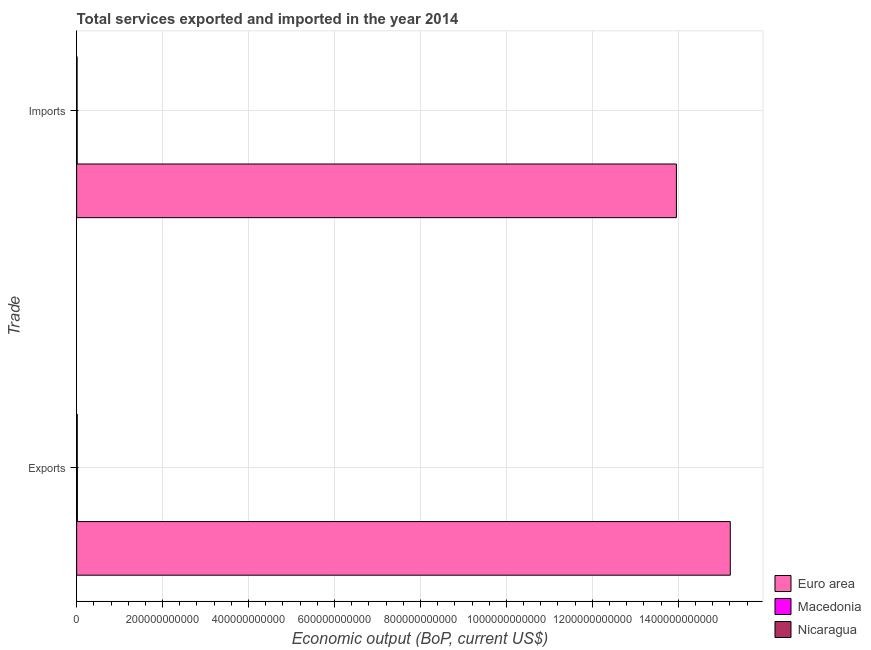How many different coloured bars are there?
Ensure brevity in your answer.  3. Are the number of bars per tick equal to the number of legend labels?
Your answer should be compact. Yes. Are the number of bars on each tick of the Y-axis equal?
Provide a short and direct response. Yes. How many bars are there on the 1st tick from the bottom?
Ensure brevity in your answer.  3. What is the label of the 2nd group of bars from the top?
Give a very brief answer. Exports. What is the amount of service imports in Nicaragua?
Give a very brief answer. 9.60e+08. Across all countries, what is the maximum amount of service exports?
Your answer should be very brief. 1.52e+12. Across all countries, what is the minimum amount of service exports?
Make the answer very short. 1.39e+09. In which country was the amount of service exports minimum?
Offer a very short reply. Nicaragua. What is the total amount of service exports in the graph?
Your answer should be compact. 1.52e+12. What is the difference between the amount of service exports in Euro area and that in Nicaragua?
Provide a succinct answer. 1.52e+12. What is the difference between the amount of service imports in Nicaragua and the amount of service exports in Euro area?
Keep it short and to the point. -1.52e+12. What is the average amount of service exports per country?
Your answer should be very brief. 5.08e+11. What is the difference between the amount of service imports and amount of service exports in Nicaragua?
Ensure brevity in your answer.  -4.28e+08. What is the ratio of the amount of service imports in Euro area to that in Nicaragua?
Your response must be concise. 1453.93. What does the 1st bar from the top in Exports represents?
Make the answer very short. Nicaragua. What does the 3rd bar from the bottom in Imports represents?
Your answer should be compact. Nicaragua. How many countries are there in the graph?
Keep it short and to the point. 3. What is the difference between two consecutive major ticks on the X-axis?
Provide a short and direct response. 2.00e+11. Are the values on the major ticks of X-axis written in scientific E-notation?
Your answer should be compact. No. Does the graph contain any zero values?
Offer a terse response. No. Where does the legend appear in the graph?
Your response must be concise. Bottom right. What is the title of the graph?
Offer a terse response. Total services exported and imported in the year 2014. Does "Middle East & North Africa (all income levels)" appear as one of the legend labels in the graph?
Offer a very short reply. No. What is the label or title of the X-axis?
Your answer should be compact. Economic output (BoP, current US$). What is the label or title of the Y-axis?
Keep it short and to the point. Trade. What is the Economic output (BoP, current US$) in Euro area in Exports?
Offer a very short reply. 1.52e+12. What is the Economic output (BoP, current US$) in Macedonia in Exports?
Keep it short and to the point. 1.70e+09. What is the Economic output (BoP, current US$) of Nicaragua in Exports?
Give a very brief answer. 1.39e+09. What is the Economic output (BoP, current US$) of Euro area in Imports?
Your answer should be very brief. 1.40e+12. What is the Economic output (BoP, current US$) in Macedonia in Imports?
Your answer should be compact. 1.22e+09. What is the Economic output (BoP, current US$) of Nicaragua in Imports?
Give a very brief answer. 9.60e+08. Across all Trade, what is the maximum Economic output (BoP, current US$) in Euro area?
Give a very brief answer. 1.52e+12. Across all Trade, what is the maximum Economic output (BoP, current US$) in Macedonia?
Keep it short and to the point. 1.70e+09. Across all Trade, what is the maximum Economic output (BoP, current US$) of Nicaragua?
Offer a very short reply. 1.39e+09. Across all Trade, what is the minimum Economic output (BoP, current US$) in Euro area?
Provide a succinct answer. 1.40e+12. Across all Trade, what is the minimum Economic output (BoP, current US$) of Macedonia?
Keep it short and to the point. 1.22e+09. Across all Trade, what is the minimum Economic output (BoP, current US$) in Nicaragua?
Ensure brevity in your answer.  9.60e+08. What is the total Economic output (BoP, current US$) of Euro area in the graph?
Ensure brevity in your answer.  2.92e+12. What is the total Economic output (BoP, current US$) in Macedonia in the graph?
Offer a very short reply. 2.92e+09. What is the total Economic output (BoP, current US$) in Nicaragua in the graph?
Provide a short and direct response. 2.35e+09. What is the difference between the Economic output (BoP, current US$) of Euro area in Exports and that in Imports?
Offer a terse response. 1.25e+11. What is the difference between the Economic output (BoP, current US$) in Macedonia in Exports and that in Imports?
Provide a short and direct response. 4.72e+08. What is the difference between the Economic output (BoP, current US$) of Nicaragua in Exports and that in Imports?
Offer a terse response. 4.28e+08. What is the difference between the Economic output (BoP, current US$) of Euro area in Exports and the Economic output (BoP, current US$) of Macedonia in Imports?
Offer a terse response. 1.52e+12. What is the difference between the Economic output (BoP, current US$) of Euro area in Exports and the Economic output (BoP, current US$) of Nicaragua in Imports?
Make the answer very short. 1.52e+12. What is the difference between the Economic output (BoP, current US$) of Macedonia in Exports and the Economic output (BoP, current US$) of Nicaragua in Imports?
Offer a very short reply. 7.36e+08. What is the average Economic output (BoP, current US$) of Euro area per Trade?
Keep it short and to the point. 1.46e+12. What is the average Economic output (BoP, current US$) of Macedonia per Trade?
Provide a short and direct response. 1.46e+09. What is the average Economic output (BoP, current US$) in Nicaragua per Trade?
Offer a very short reply. 1.17e+09. What is the difference between the Economic output (BoP, current US$) of Euro area and Economic output (BoP, current US$) of Macedonia in Exports?
Offer a terse response. 1.52e+12. What is the difference between the Economic output (BoP, current US$) in Euro area and Economic output (BoP, current US$) in Nicaragua in Exports?
Your response must be concise. 1.52e+12. What is the difference between the Economic output (BoP, current US$) in Macedonia and Economic output (BoP, current US$) in Nicaragua in Exports?
Your response must be concise. 3.07e+08. What is the difference between the Economic output (BoP, current US$) of Euro area and Economic output (BoP, current US$) of Macedonia in Imports?
Offer a very short reply. 1.39e+12. What is the difference between the Economic output (BoP, current US$) in Euro area and Economic output (BoP, current US$) in Nicaragua in Imports?
Provide a succinct answer. 1.39e+12. What is the difference between the Economic output (BoP, current US$) in Macedonia and Economic output (BoP, current US$) in Nicaragua in Imports?
Offer a terse response. 2.64e+08. What is the ratio of the Economic output (BoP, current US$) of Euro area in Exports to that in Imports?
Keep it short and to the point. 1.09. What is the ratio of the Economic output (BoP, current US$) of Macedonia in Exports to that in Imports?
Offer a terse response. 1.39. What is the ratio of the Economic output (BoP, current US$) of Nicaragua in Exports to that in Imports?
Your answer should be very brief. 1.45. What is the difference between the highest and the second highest Economic output (BoP, current US$) in Euro area?
Provide a succinct answer. 1.25e+11. What is the difference between the highest and the second highest Economic output (BoP, current US$) of Macedonia?
Offer a terse response. 4.72e+08. What is the difference between the highest and the second highest Economic output (BoP, current US$) of Nicaragua?
Your response must be concise. 4.28e+08. What is the difference between the highest and the lowest Economic output (BoP, current US$) in Euro area?
Keep it short and to the point. 1.25e+11. What is the difference between the highest and the lowest Economic output (BoP, current US$) in Macedonia?
Make the answer very short. 4.72e+08. What is the difference between the highest and the lowest Economic output (BoP, current US$) in Nicaragua?
Keep it short and to the point. 4.28e+08. 